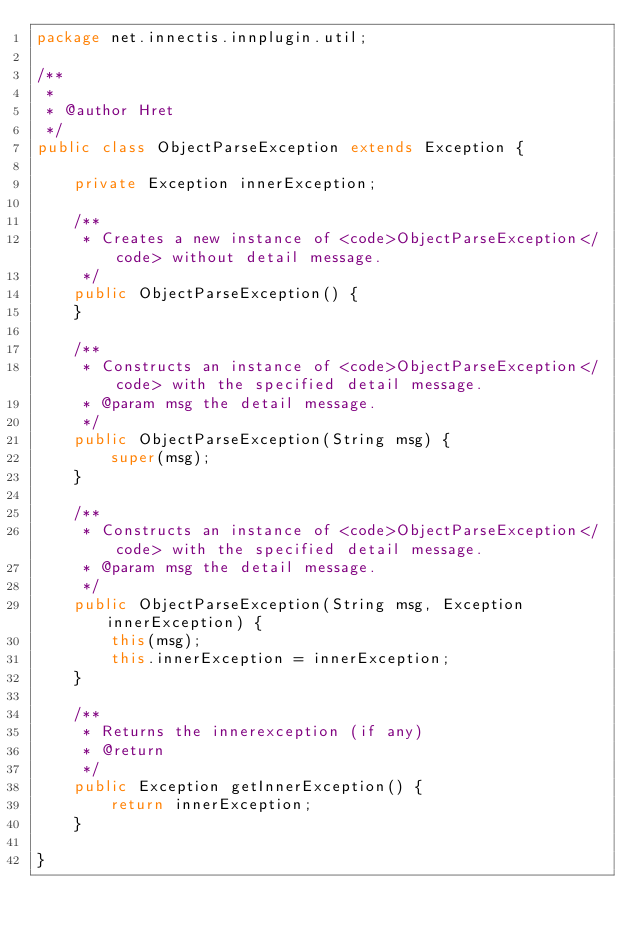Convert code to text. <code><loc_0><loc_0><loc_500><loc_500><_Java_>package net.innectis.innplugin.util;

/**
 *
 * @author Hret
 */
public class ObjectParseException extends Exception {

    private Exception innerException;

    /**
     * Creates a new instance of <code>ObjectParseException</code> without detail message.
     */
    public ObjectParseException() {
    }

    /**
     * Constructs an instance of <code>ObjectParseException</code> with the specified detail message.
     * @param msg the detail message.
     */
    public ObjectParseException(String msg) {
        super(msg);
    }

    /**
     * Constructs an instance of <code>ObjectParseException</code> with the specified detail message.
     * @param msg the detail message.
     */
    public ObjectParseException(String msg, Exception innerException) {
        this(msg);
        this.innerException = innerException;
    }

    /**
     * Returns the innerexception (if any)
     * @return
     */
    public Exception getInnerException() {
        return innerException;
    }
    
}
</code> 